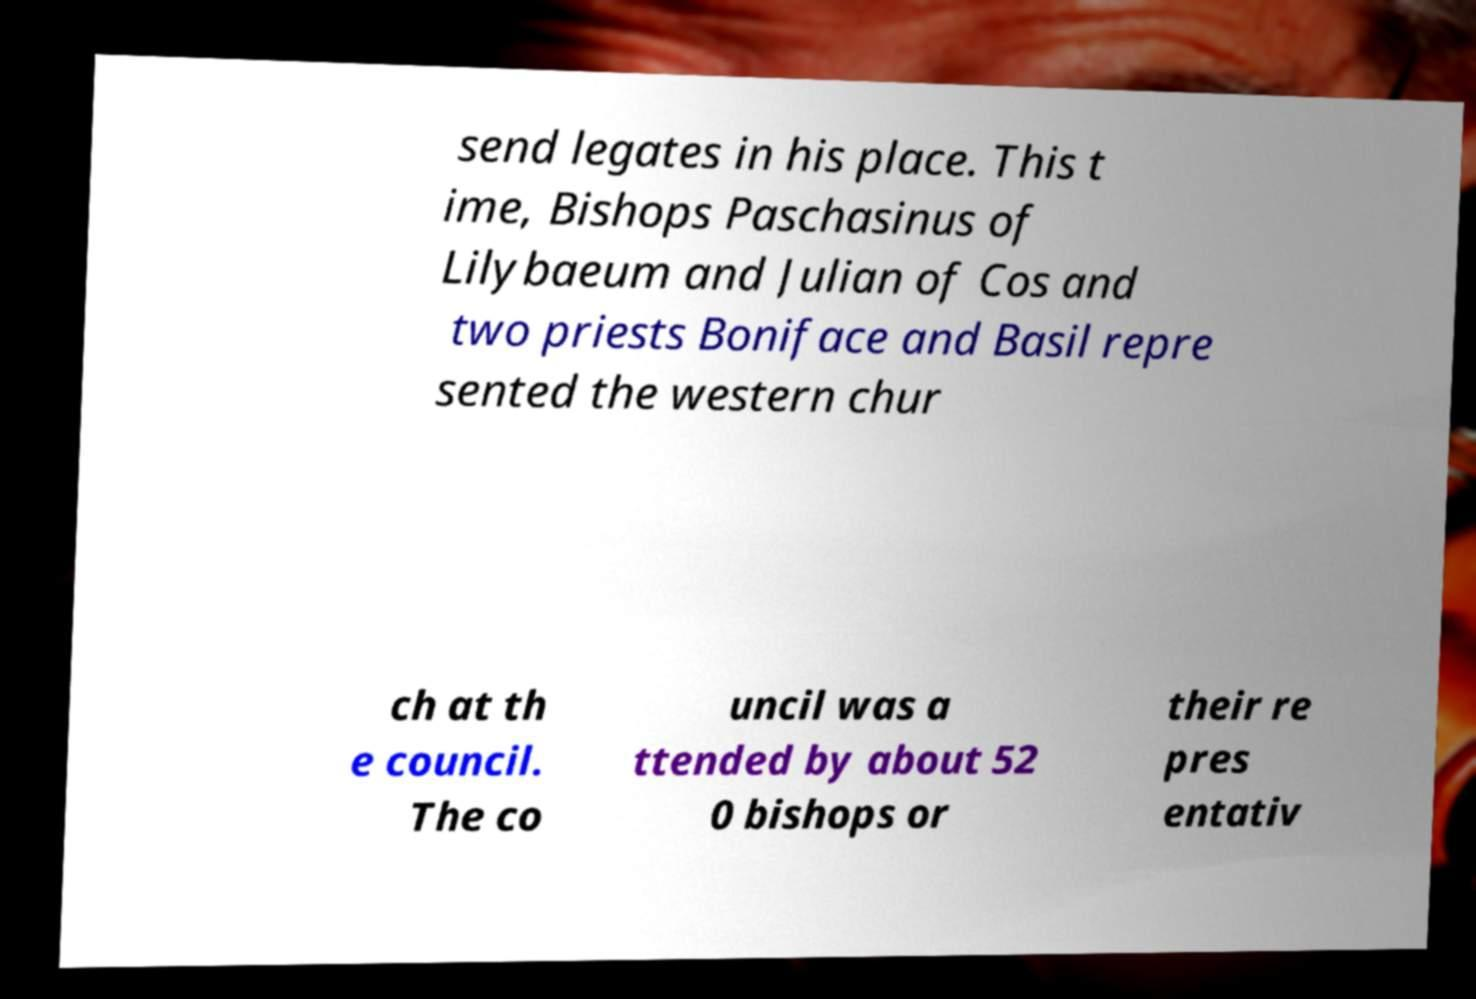What messages or text are displayed in this image? I need them in a readable, typed format. send legates in his place. This t ime, Bishops Paschasinus of Lilybaeum and Julian of Cos and two priests Boniface and Basil repre sented the western chur ch at th e council. The co uncil was a ttended by about 52 0 bishops or their re pres entativ 